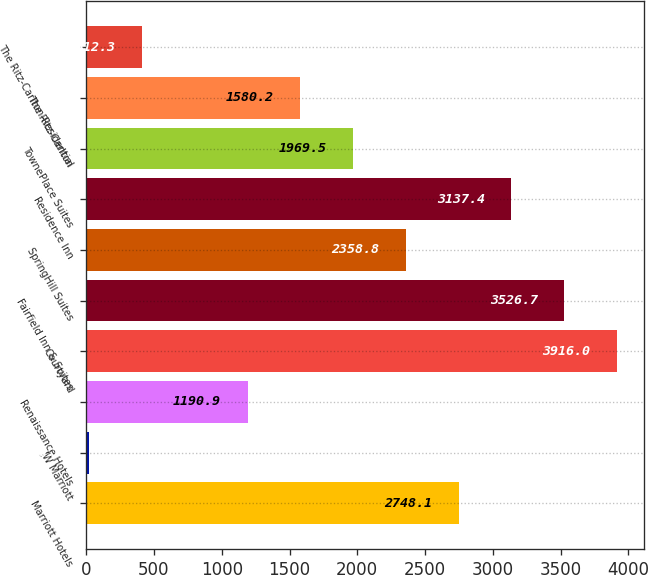Convert chart. <chart><loc_0><loc_0><loc_500><loc_500><bar_chart><fcel>Marriott Hotels<fcel>JW Marriott<fcel>Renaissance Hotels<fcel>Courtyard<fcel>Fairfield Inn & Suites<fcel>SpringHill Suites<fcel>Residence Inn<fcel>TownePlace Suites<fcel>The Ritz-Carlton<fcel>The Ritz-Carlton-Residential<nl><fcel>2748.1<fcel>23<fcel>1190.9<fcel>3916<fcel>3526.7<fcel>2358.8<fcel>3137.4<fcel>1969.5<fcel>1580.2<fcel>412.3<nl></chart> 